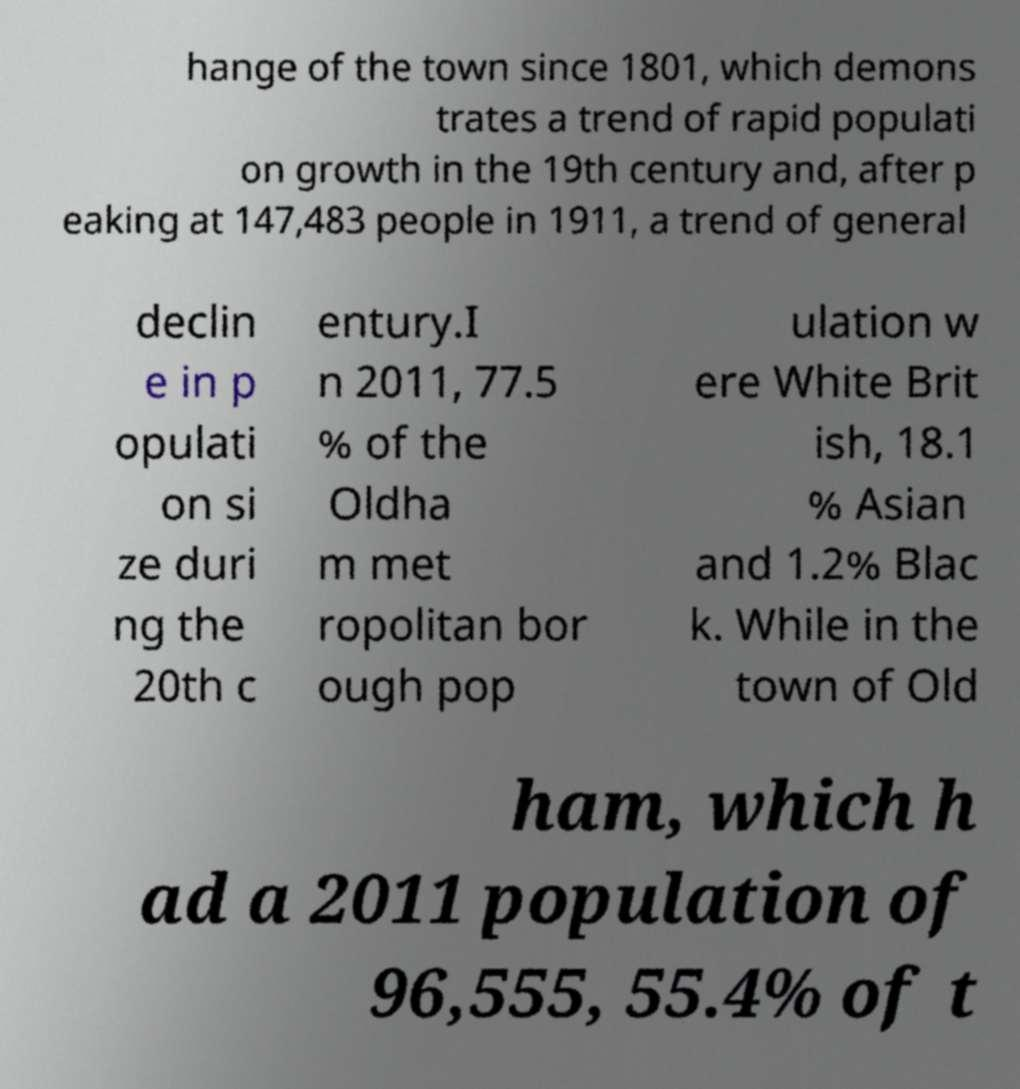Could you extract and type out the text from this image? hange of the town since 1801, which demons trates a trend of rapid populati on growth in the 19th century and, after p eaking at 147,483 people in 1911, a trend of general declin e in p opulati on si ze duri ng the 20th c entury.I n 2011, 77.5 % of the Oldha m met ropolitan bor ough pop ulation w ere White Brit ish, 18.1 % Asian and 1.2% Blac k. While in the town of Old ham, which h ad a 2011 population of 96,555, 55.4% of t 